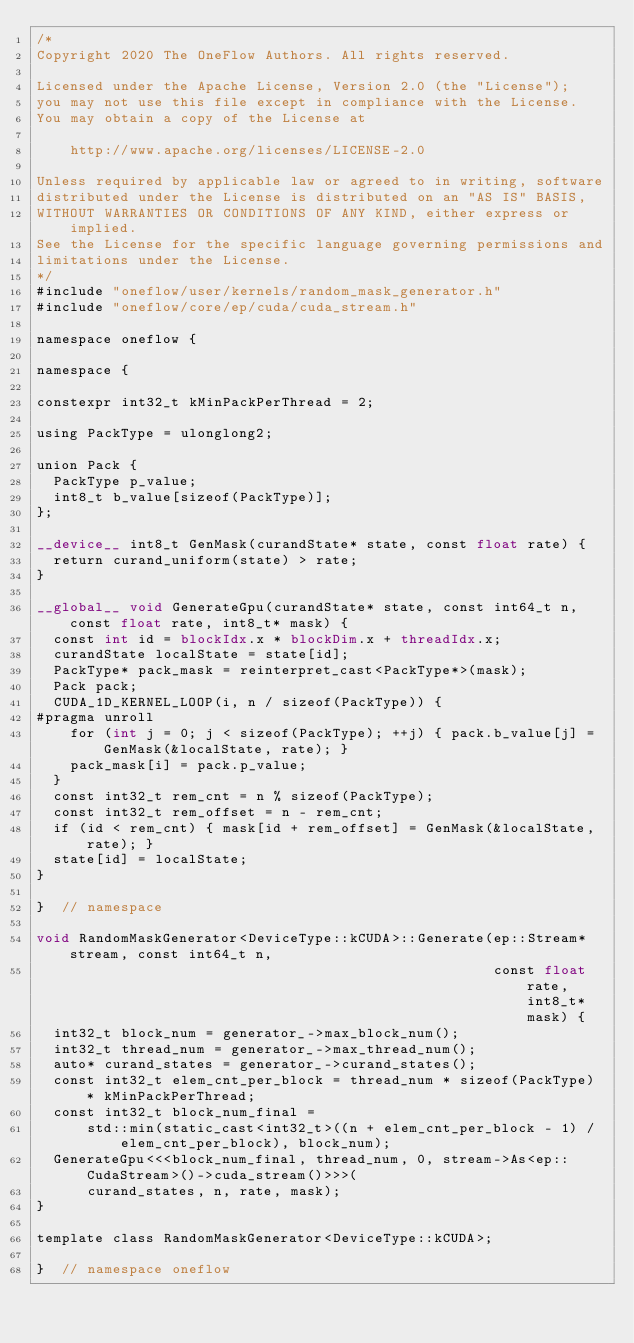<code> <loc_0><loc_0><loc_500><loc_500><_Cuda_>/*
Copyright 2020 The OneFlow Authors. All rights reserved.

Licensed under the Apache License, Version 2.0 (the "License");
you may not use this file except in compliance with the License.
You may obtain a copy of the License at

    http://www.apache.org/licenses/LICENSE-2.0

Unless required by applicable law or agreed to in writing, software
distributed under the License is distributed on an "AS IS" BASIS,
WITHOUT WARRANTIES OR CONDITIONS OF ANY KIND, either express or implied.
See the License for the specific language governing permissions and
limitations under the License.
*/
#include "oneflow/user/kernels/random_mask_generator.h"
#include "oneflow/core/ep/cuda/cuda_stream.h"

namespace oneflow {

namespace {

constexpr int32_t kMinPackPerThread = 2;

using PackType = ulonglong2;

union Pack {
  PackType p_value;
  int8_t b_value[sizeof(PackType)];
};

__device__ int8_t GenMask(curandState* state, const float rate) {
  return curand_uniform(state) > rate;
}

__global__ void GenerateGpu(curandState* state, const int64_t n, const float rate, int8_t* mask) {
  const int id = blockIdx.x * blockDim.x + threadIdx.x;
  curandState localState = state[id];
  PackType* pack_mask = reinterpret_cast<PackType*>(mask);
  Pack pack;
  CUDA_1D_KERNEL_LOOP(i, n / sizeof(PackType)) {
#pragma unroll
    for (int j = 0; j < sizeof(PackType); ++j) { pack.b_value[j] = GenMask(&localState, rate); }
    pack_mask[i] = pack.p_value;
  }
  const int32_t rem_cnt = n % sizeof(PackType);
  const int32_t rem_offset = n - rem_cnt;
  if (id < rem_cnt) { mask[id + rem_offset] = GenMask(&localState, rate); }
  state[id] = localState;
}

}  // namespace

void RandomMaskGenerator<DeviceType::kCUDA>::Generate(ep::Stream* stream, const int64_t n,
                                                      const float rate, int8_t* mask) {
  int32_t block_num = generator_->max_block_num();
  int32_t thread_num = generator_->max_thread_num();
  auto* curand_states = generator_->curand_states();
  const int32_t elem_cnt_per_block = thread_num * sizeof(PackType) * kMinPackPerThread;
  const int32_t block_num_final =
      std::min(static_cast<int32_t>((n + elem_cnt_per_block - 1) / elem_cnt_per_block), block_num);
  GenerateGpu<<<block_num_final, thread_num, 0, stream->As<ep::CudaStream>()->cuda_stream()>>>(
      curand_states, n, rate, mask);
}

template class RandomMaskGenerator<DeviceType::kCUDA>;

}  // namespace oneflow
</code> 